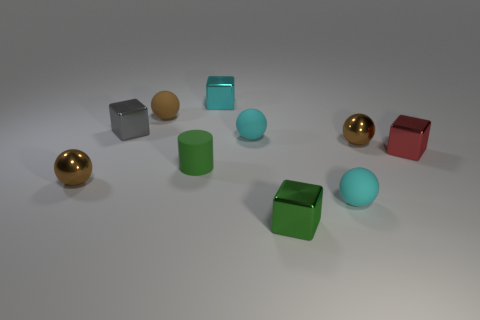Subtract all cyan shiny blocks. How many blocks are left? 3 Subtract all cyan balls. How many balls are left? 3 Subtract all cylinders. How many objects are left? 9 Subtract all gray cubes. How many purple spheres are left? 0 Subtract all red objects. Subtract all brown rubber balls. How many objects are left? 8 Add 9 tiny green rubber objects. How many tiny green rubber objects are left? 10 Add 5 small cyan rubber balls. How many small cyan rubber balls exist? 7 Subtract 2 cyan balls. How many objects are left? 8 Subtract 2 cubes. How many cubes are left? 2 Subtract all cyan blocks. Subtract all cyan cylinders. How many blocks are left? 3 